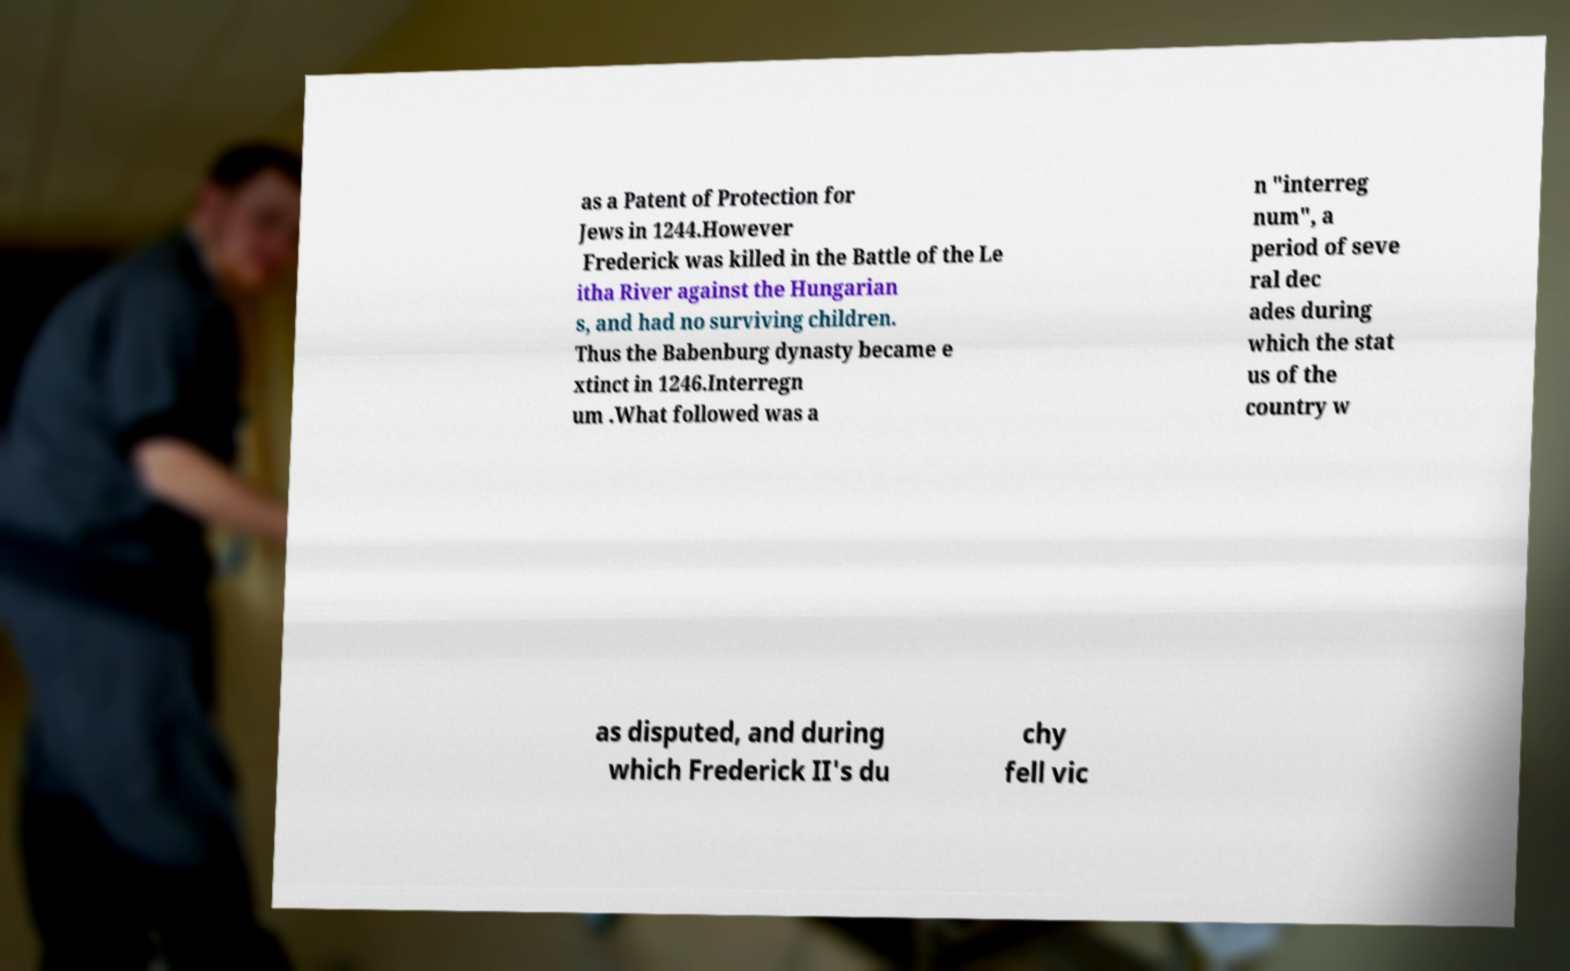Can you accurately transcribe the text from the provided image for me? as a Patent of Protection for Jews in 1244.However Frederick was killed in the Battle of the Le itha River against the Hungarian s, and had no surviving children. Thus the Babenburg dynasty became e xtinct in 1246.Interregn um .What followed was a n "interreg num", a period of seve ral dec ades during which the stat us of the country w as disputed, and during which Frederick II's du chy fell vic 